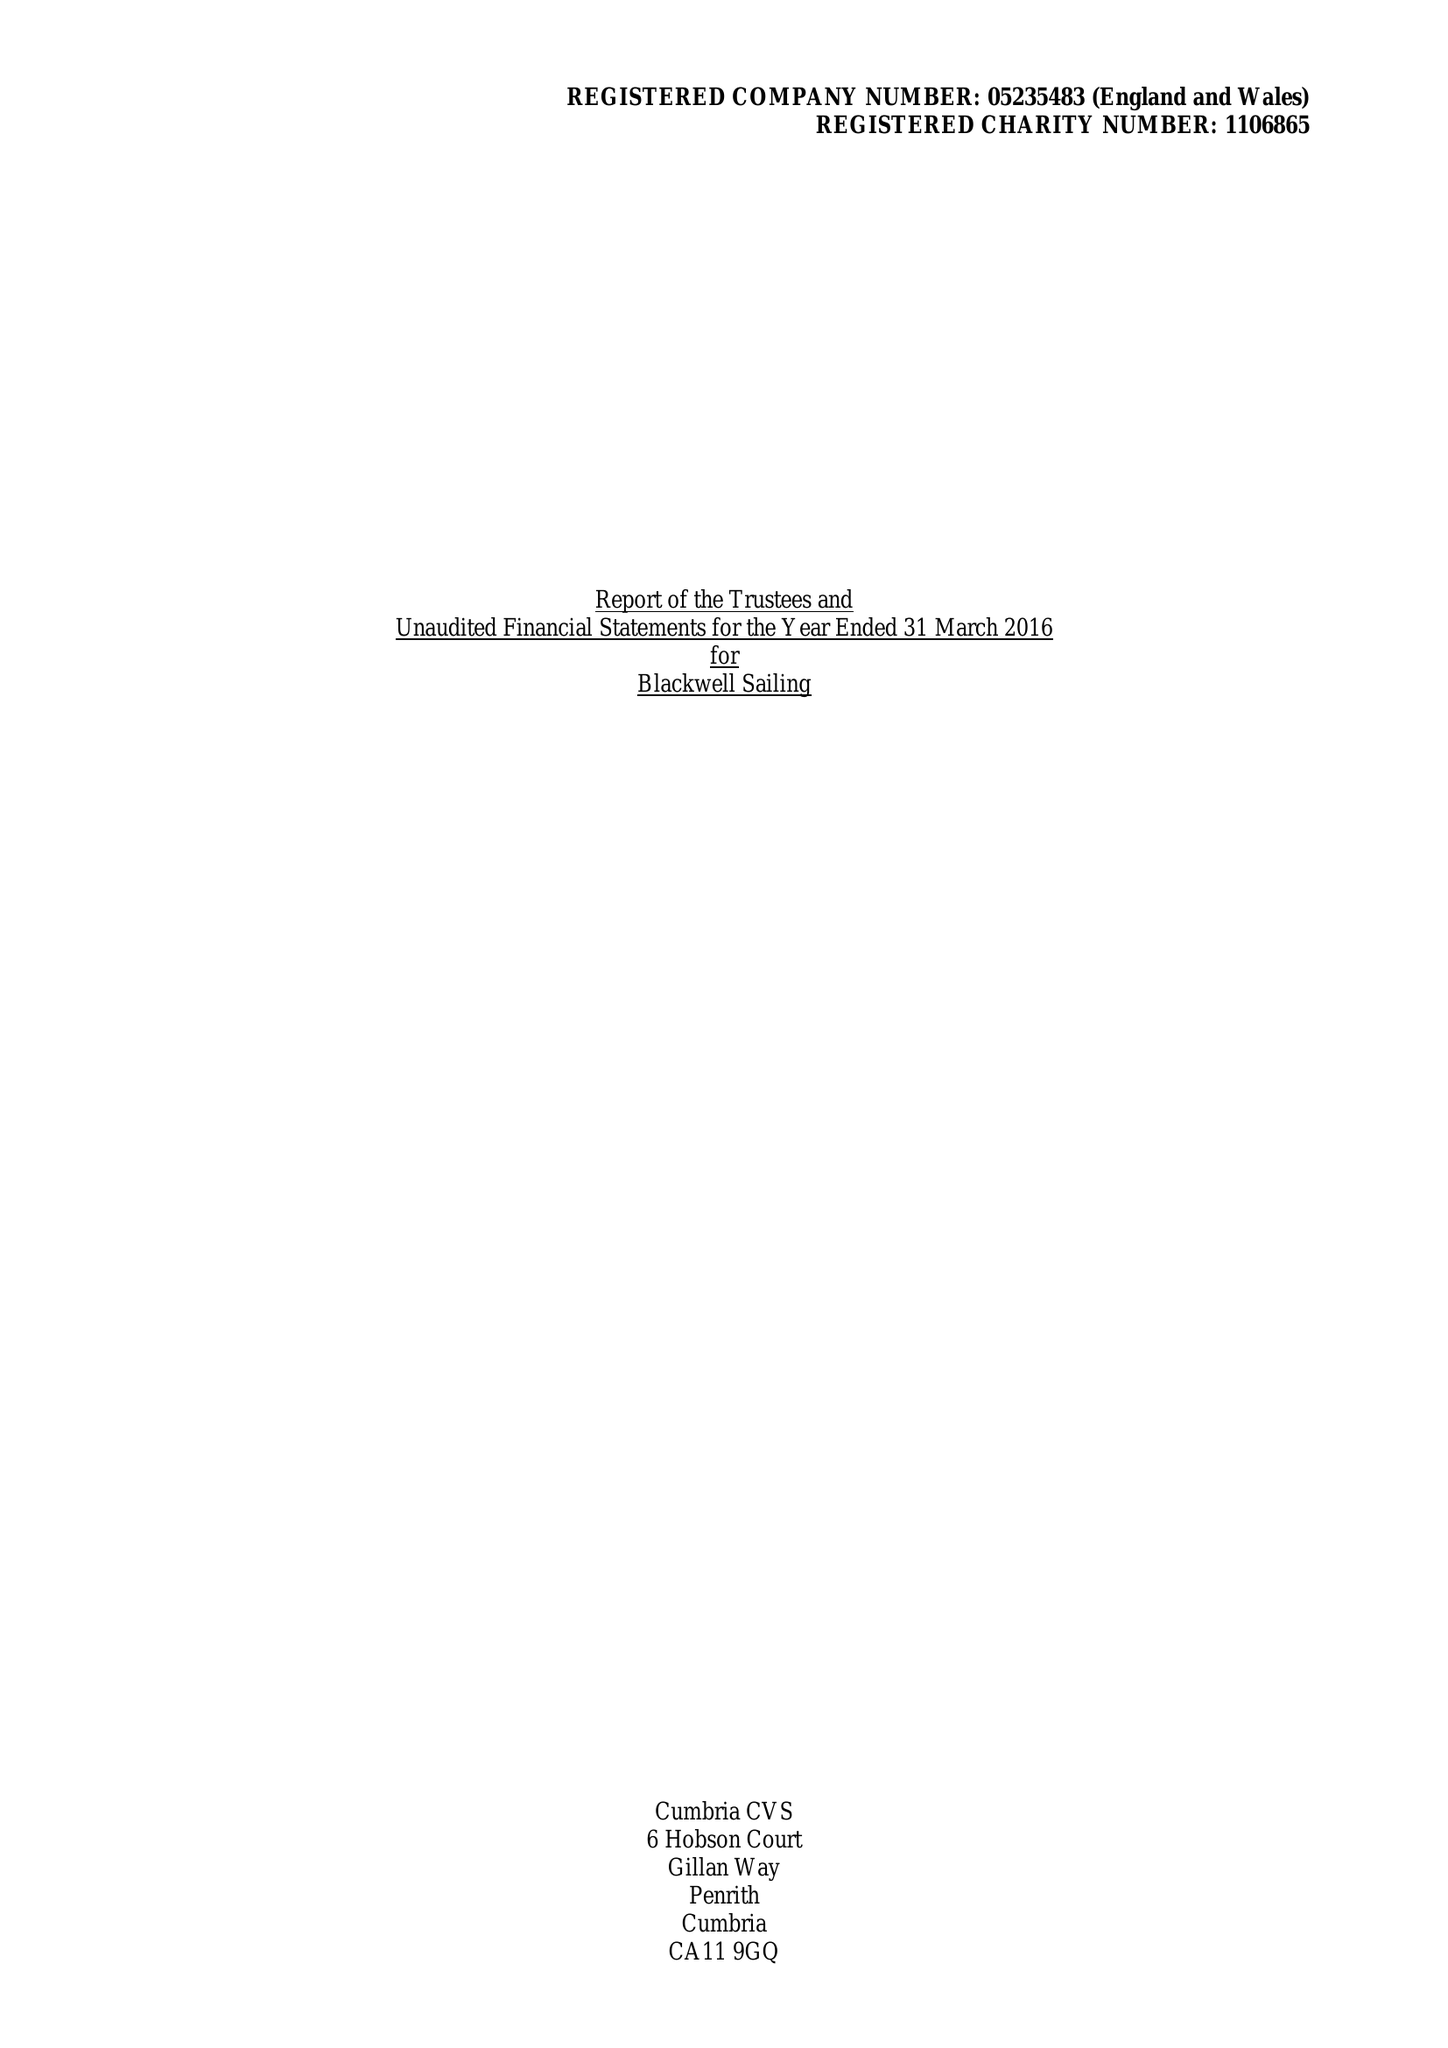What is the value for the spending_annually_in_british_pounds?
Answer the question using a single word or phrase. 69152.00 